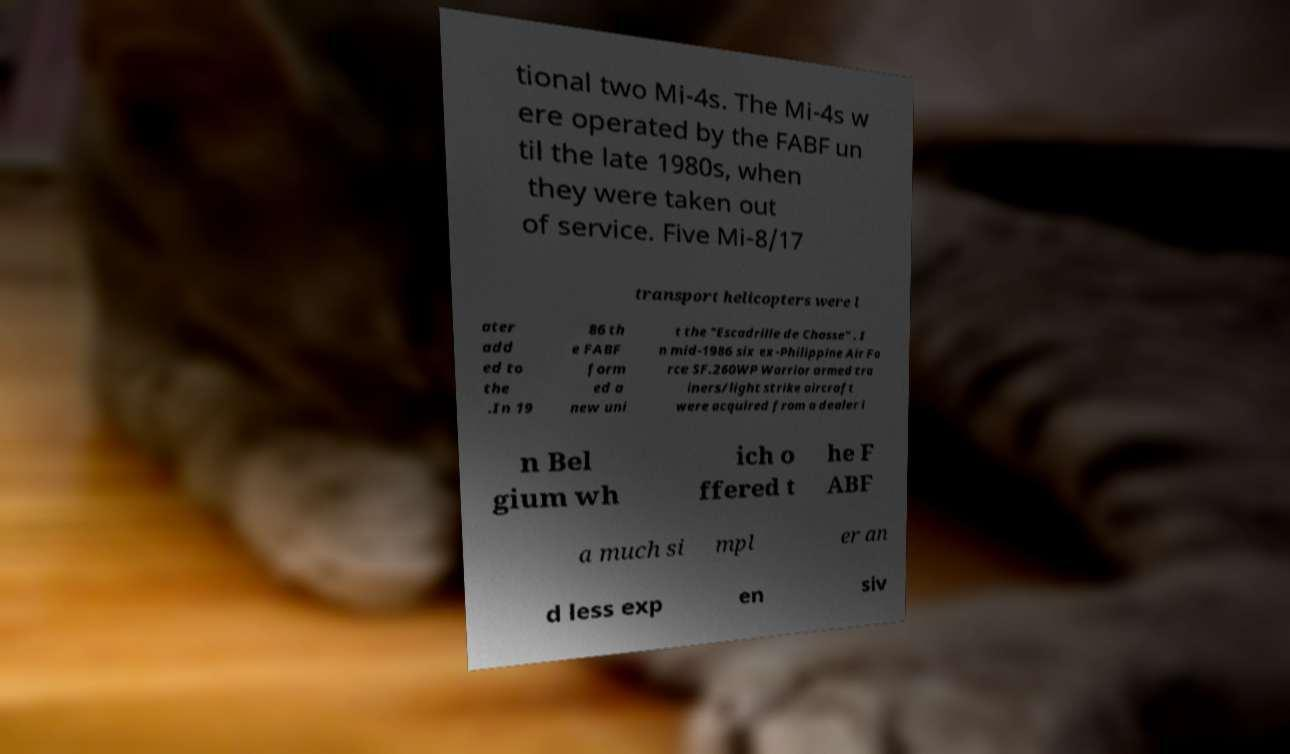Please identify and transcribe the text found in this image. tional two Mi-4s. The Mi-4s w ere operated by the FABF un til the late 1980s, when they were taken out of service. Five Mi-8/17 transport helicopters were l ater add ed to the .In 19 86 th e FABF form ed a new uni t the "Escadrille de Chasse" . I n mid-1986 six ex-Philippine Air Fo rce SF.260WP Warrior armed tra iners/light strike aircraft were acquired from a dealer i n Bel gium wh ich o ffered t he F ABF a much si mpl er an d less exp en siv 